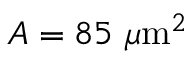<formula> <loc_0><loc_0><loc_500><loc_500>A = 8 5 \mu m ^ { 2 }</formula> 